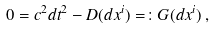Convert formula to latex. <formula><loc_0><loc_0><loc_500><loc_500>0 = c ^ { 2 } d t ^ { 2 } - D ( d x ^ { i } ) = \colon G ( d x ^ { i } ) \, ,</formula> 